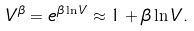<formula> <loc_0><loc_0><loc_500><loc_500>V ^ { \beta } = e ^ { \beta \ln { V } } \approx 1 + \beta \ln { V } .</formula> 